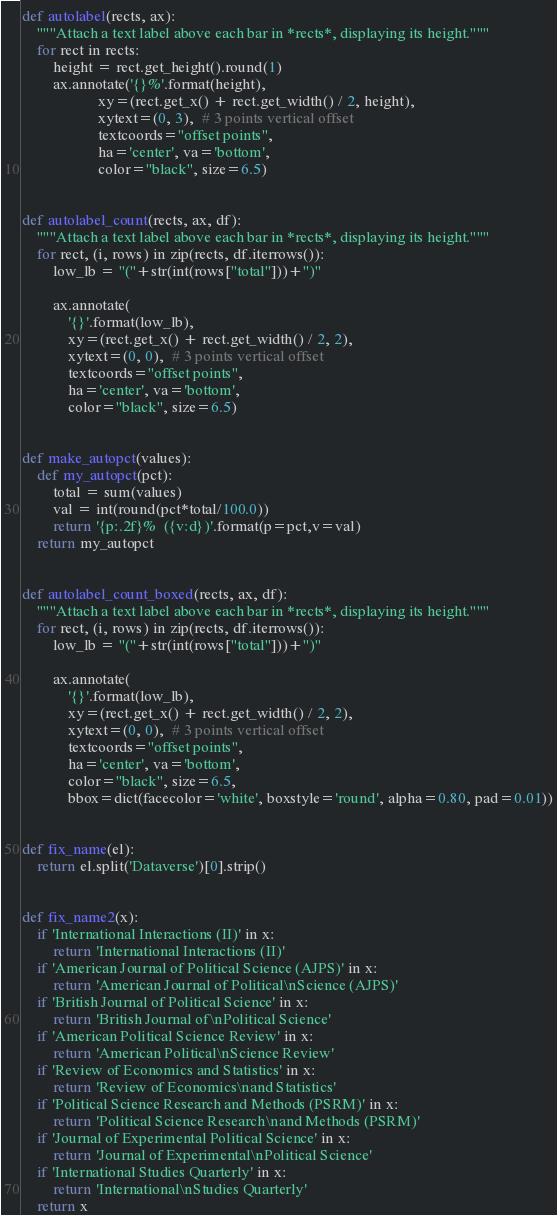<code> <loc_0><loc_0><loc_500><loc_500><_Python_>def autolabel(rects, ax):
    """Attach a text label above each bar in *rects*, displaying its height."""
    for rect in rects:
        height = rect.get_height().round(1)
        ax.annotate('{}%'.format(height),
                    xy=(rect.get_x() + rect.get_width() / 2, height),
                    xytext=(0, 3),  # 3 points vertical offset
                    textcoords="offset points",
                    ha='center', va='bottom', 
                    color="black", size=6.5)


def autolabel_count(rects, ax, df):
    """Attach a text label above each bar in *rects*, displaying its height."""
    for rect, (i, rows) in zip(rects, df.iterrows()):
        low_lb = "("+str(int(rows["total"]))+")"

        ax.annotate(
            '{}'.format(low_lb),
            xy=(rect.get_x() + rect.get_width() / 2, 2),
            xytext=(0, 0),  # 3 points vertical offset
            textcoords="offset points",
            ha='center', va='bottom', 
            color="black", size=6.5)


def make_autopct(values):
    def my_autopct(pct):
        total = sum(values)
        val = int(round(pct*total/100.0))
        return '{p:.2f}%  ({v:d})'.format(p=pct,v=val)
    return my_autopct
    

def autolabel_count_boxed(rects, ax, df):
    """Attach a text label above each bar in *rects*, displaying its height."""
    for rect, (i, rows) in zip(rects, df.iterrows()):
        low_lb = "("+str(int(rows["total"]))+")"

        ax.annotate(
            '{}'.format(low_lb),
            xy=(rect.get_x() + rect.get_width() / 2, 2),
            xytext=(0, 0),  # 3 points vertical offset
            textcoords="offset points",
            ha='center', va='bottom', 
            color="black", size=6.5,
            bbox=dict(facecolor='white', boxstyle='round', alpha=0.80, pad=0.01))


def fix_name(el):
    return el.split('Dataverse')[0].strip()


def fix_name2(x):
    if 'International Interactions (II)' in x:
        return 'International Interactions (II)'
    if 'American Journal of Political Science (AJPS)' in x:
        return 'American Journal of Political\nScience (AJPS)'
    if 'British Journal of Political Science' in x:
        return 'British Journal of\nPolitical Science'
    if 'American Political Science Review' in x:
        return 'American Political\nScience Review'
    if 'Review of Economics and Statistics' in x:
        return 'Review of Economics\nand Statistics'
    if 'Political Science Research and Methods (PSRM)' in x:
        return 'Political Science Research\nand Methods (PSRM)'
    if 'Journal of Experimental Political Science' in x:
        return 'Journal of Experimental\nPolitical Science'
    if 'International Studies Quarterly' in x:
        return 'International\nStudies Quarterly'
    return x</code> 